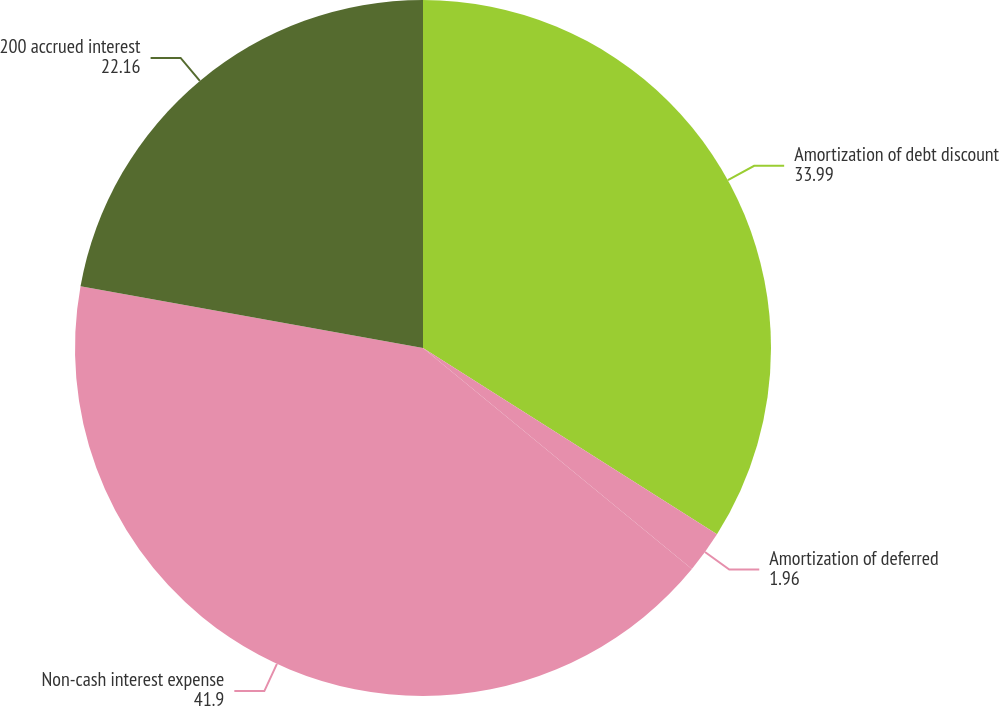Convert chart to OTSL. <chart><loc_0><loc_0><loc_500><loc_500><pie_chart><fcel>Amortization of debt discount<fcel>Amortization of deferred<fcel>Non-cash interest expense<fcel>200 accrued interest<nl><fcel>33.99%<fcel>1.96%<fcel>41.9%<fcel>22.16%<nl></chart> 